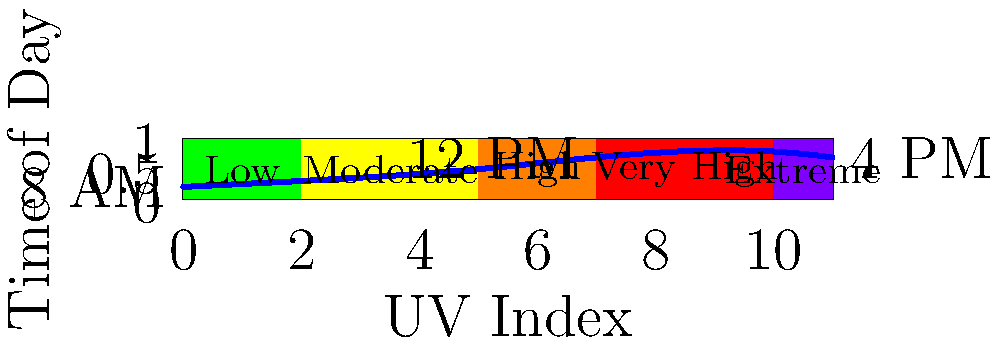Based on the UV index chart for a typical summer day in Chapel Hill, during which time period would it be safest for outdoor activities without sun protection? To determine the safest time for outdoor activities without sun protection, we need to analyze the UV index chart:

1. The chart shows UV index levels throughout the day, with lower values indicating safer conditions.
2. The UV index curve starts low in the morning, peaks around midday, and decreases in the afternoon.
3. UV index categories are:
   - Low (0-2): Green
   - Moderate (3-5): Yellow
   - High (6-7): Orange
   - Very High (8-10): Red
   - Extreme (11+): Purple

4. The curve begins in the "Low" category (green) early in the morning, around 8 AM.
5. It quickly rises through "Moderate" and "High" categories, reaching "Very High" around midday (12 PM).
6. In the afternoon, it gradually decreases, returning to the "High" category by 4 PM.

7. The safest time for outdoor activities without sun protection is when the UV index is in the "Low" category (0-2).
8. This occurs only in the early morning hours, shortly after 8 AM, before the curve rises into the "Moderate" category.

Therefore, the safest time for outdoor activities without sun protection would be in the early morning, soon after 8 AM.
Answer: Early morning (shortly after 8 AM) 